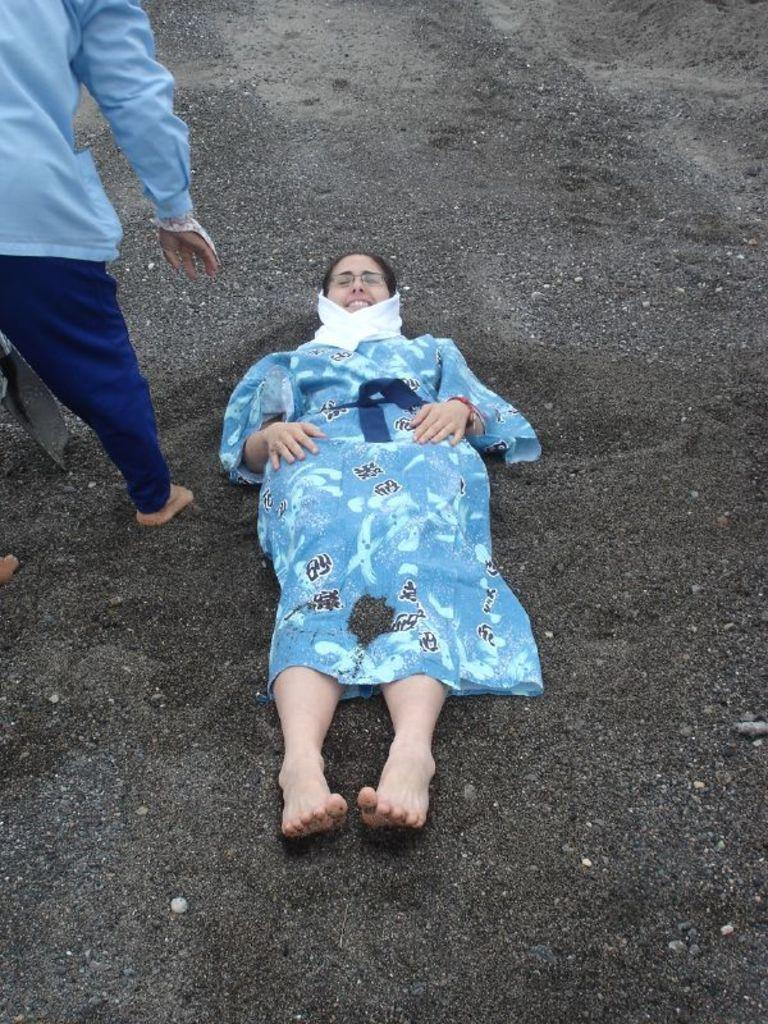What is the lady in the image doing? The lady is lying on the ground in the image. What is the lady wearing? The lady is wearing a blue frock. Who else is present in the image? There is a person standing in the image. What is the person wearing? The person is wearing a blue shirt and pants. What type of surface is the lady and person lying and standing on? The ground is covered in sand. What type of yoke can be seen in the image? There is no yoke present in the image. How does the form of the lady change throughout the image? The image is a still photograph, so the lady's form does not change throughout the image. 